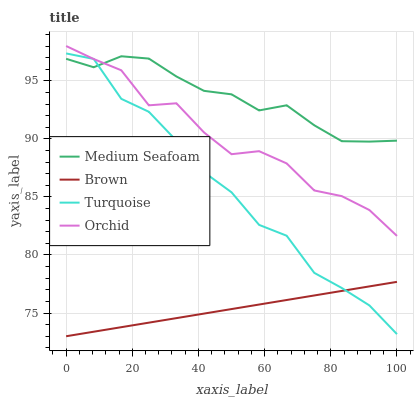Does Brown have the minimum area under the curve?
Answer yes or no. Yes. Does Medium Seafoam have the maximum area under the curve?
Answer yes or no. Yes. Does Turquoise have the minimum area under the curve?
Answer yes or no. No. Does Turquoise have the maximum area under the curve?
Answer yes or no. No. Is Brown the smoothest?
Answer yes or no. Yes. Is Orchid the roughest?
Answer yes or no. Yes. Is Turquoise the smoothest?
Answer yes or no. No. Is Turquoise the roughest?
Answer yes or no. No. Does Brown have the lowest value?
Answer yes or no. Yes. Does Turquoise have the lowest value?
Answer yes or no. No. Does Orchid have the highest value?
Answer yes or no. Yes. Does Turquoise have the highest value?
Answer yes or no. No. Is Brown less than Medium Seafoam?
Answer yes or no. Yes. Is Orchid greater than Brown?
Answer yes or no. Yes. Does Medium Seafoam intersect Turquoise?
Answer yes or no. Yes. Is Medium Seafoam less than Turquoise?
Answer yes or no. No. Is Medium Seafoam greater than Turquoise?
Answer yes or no. No. Does Brown intersect Medium Seafoam?
Answer yes or no. No. 